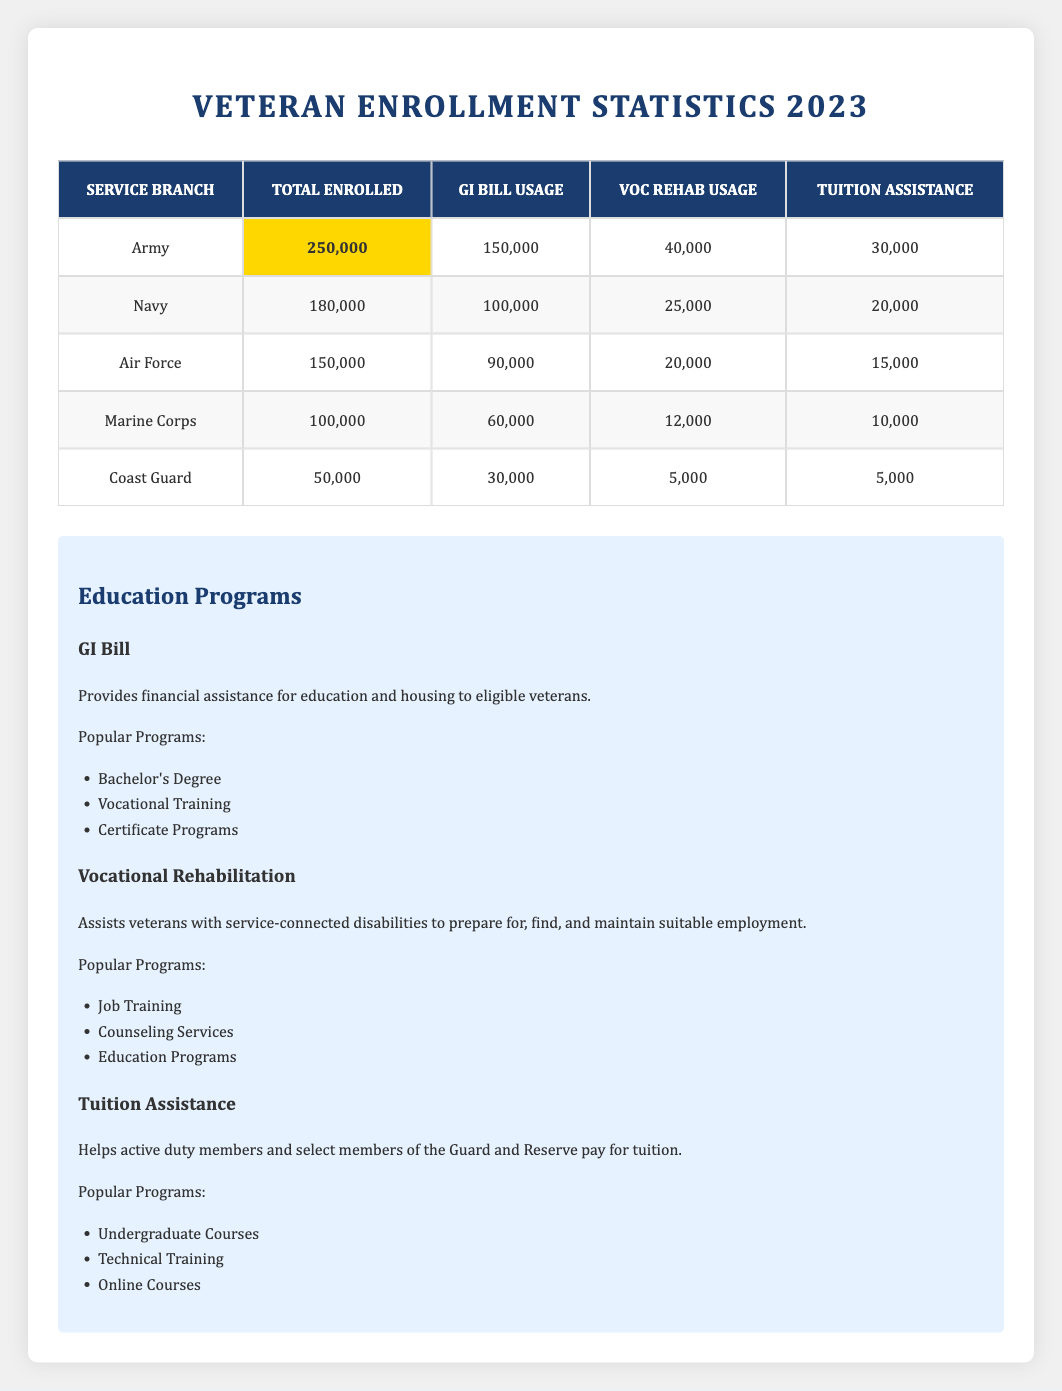What is the total number of veterans enrolled in the Army? The table shows that the total number of veterans enrolled in the Army is highlighted as 250,000.
Answer: 250,000 How many veterans utilized the GI Bill in the Air Force? According to the table, the GI Bill usage for the Air Force is listed as 90,000.
Answer: 90,000 Which service branch has the lowest number of total enrolled veterans? By comparing the total enrolled numbers, the Coast Guard has the lowest with 50,000.
Answer: Coast Guard What is the total number of veterans who used Tuition Assistance across all branches? To find this, we add the Tuition Assistance usage: 30,000 (Army) + 20,000 (Navy) + 15,000 (Air Force) + 10,000 (Marine Corps) + 5,000 (Coast Guard) = 80,000.
Answer: 80,000 Is the number of veterans using Voc Rehab in the Navy greater than those in the Army? The table shows 25,000 for the Navy and 40,000 for the Army, so the statement is false.
Answer: No If we consider the total enrollment numbers, which service branch has the highest percentage of veterans using the GI Bill? The percentages are calculated as follows: Army: (150,000/250,000) * 100 = 60%, Navy: (100,000/180,000) * 100 = 55.56%, Air Force: (90,000/150,000) * 100 = 60%, Marine Corps: (60,000/100,000) * 100 = 60%, Coast Guard: (30,000/50,000) * 100 = 60%. Since multiple branches tie at 60%, they all qualify.
Answer: Army, Air Force, Marine Corps, Coast Guard Add the total enrolled veterans from the Navy and Coast Guard, then compare to the total from the Army. Is this sum less than half of Army's enrollment? The total from Navy and Coast Guard is 180,000 + 50,000 = 230,000. Since 250,000 / 2 = 125,000, 230,000 is greater than 125,000. So, the statement is false.
Answer: No What percentage of total enrolled veterans in the Marine Corps used the GI Bill? The Marine Corps enrollment is 100,000, and those using the GI Bill are 60,000. Percentage calculation: (60,000/100,000) * 100 = 60%.
Answer: 60% Which educational program has the most popular programs listed? The table lists popular programs for three educational programs, all have three listed, therefore the statement is not specific to declare one having more than others.
Answer: All have three programs listed How does the number of veterans using Voc Rehab in the Army compare to the Air Force? The Army has 40,000 utilizing Voc Rehab while the Air Force has 20,000; thus, the Army has twice as many using this program.
Answer: Army has twice the users compared to Air Force 